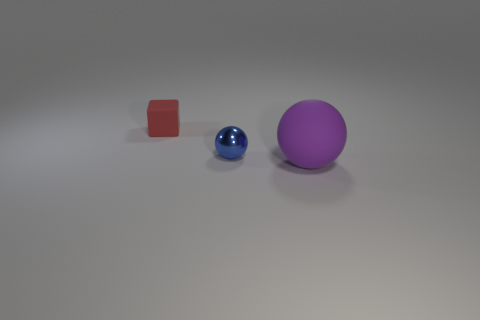Add 1 blue rubber cylinders. How many objects exist? 4 Subtract all cubes. How many objects are left? 2 Add 2 tiny blue things. How many tiny blue things are left? 3 Add 1 cyan metallic blocks. How many cyan metallic blocks exist? 1 Subtract 0 brown cubes. How many objects are left? 3 Subtract all blue shiny balls. Subtract all small things. How many objects are left? 0 